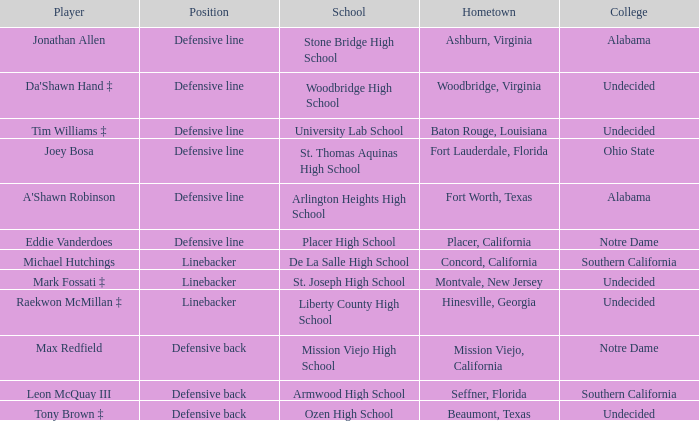What university did the athlete from liberty county high school go to? Undecided. 